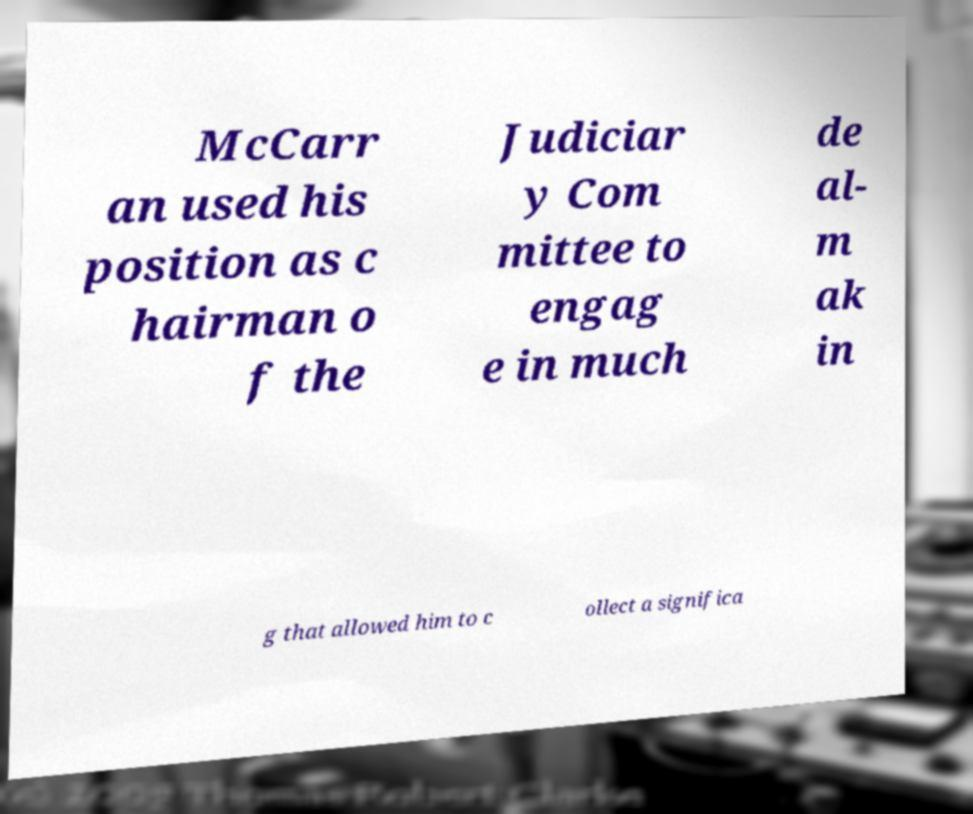Can you read and provide the text displayed in the image?This photo seems to have some interesting text. Can you extract and type it out for me? McCarr an used his position as c hairman o f the Judiciar y Com mittee to engag e in much de al- m ak in g that allowed him to c ollect a significa 